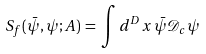Convert formula to latex. <formula><loc_0><loc_0><loc_500><loc_500>S _ { f } ( { \bar { \psi } } , \psi ; A ) \, = \, \int d ^ { D } x \, { \bar { \psi } } { \mathcal { D } } _ { c } \psi</formula> 